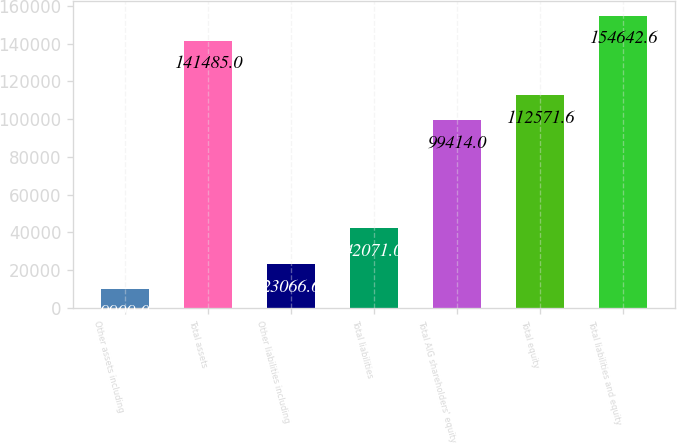Convert chart to OTSL. <chart><loc_0><loc_0><loc_500><loc_500><bar_chart><fcel>Other assets including<fcel>Total assets<fcel>Other liabilities including<fcel>Total liabilities<fcel>Total AIG shareholders' equity<fcel>Total equity<fcel>Total liabilities and equity<nl><fcel>9909<fcel>141485<fcel>23066.6<fcel>42071<fcel>99414<fcel>112572<fcel>154643<nl></chart> 